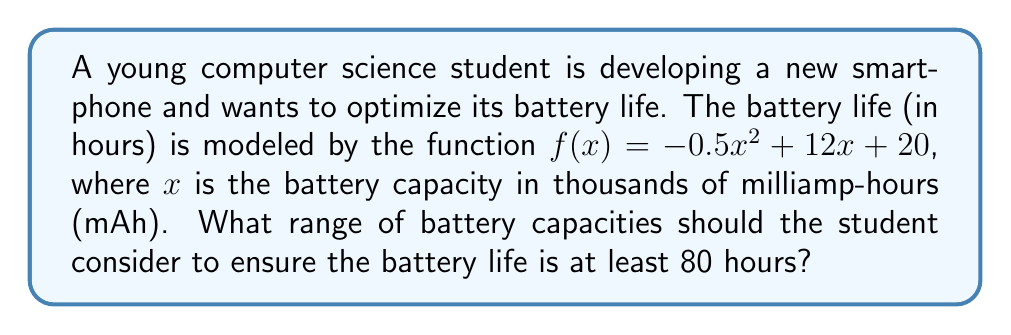Give your solution to this math problem. Let's approach this step-by-step:

1) We need to find the values of $x$ where $f(x) \geq 80$. This can be written as an inequality:

   $-0.5x^2 + 12x + 20 \geq 80$

2) Rearrange the inequality:
   
   $-0.5x^2 + 12x - 60 \geq 0$

3) This is a quadratic inequality. To solve it, we first find the roots of the corresponding quadratic equation:

   $-0.5x^2 + 12x - 60 = 0$

4) We can solve this using the quadratic formula: $x = \frac{-b \pm \sqrt{b^2 - 4ac}}{2a}$
   
   Here, $a = -0.5$, $b = 12$, and $c = -60$

5) Plugging into the formula:

   $x = \frac{-12 \pm \sqrt{12^2 - 4(-0.5)(-60)}}{2(-0.5)}$
   
   $= \frac{-12 \pm \sqrt{144 - 120}}{-1}$
   
   $= \frac{-12 \pm \sqrt{24}}{-1}$
   
   $= \frac{-12 \pm 4.9}{-1}$

6) This gives us two solutions:

   $x_1 = \frac{-12 - 4.9}{-1} \approx 16.9$
   
   $x_2 = \frac{-12 + 4.9}{-1} \approx 7.1$

7) Since the parabola opens downward (coefficient of $x^2$ is negative), the inequality $f(x) \geq 80$ is satisfied when $x$ is between these two roots.

Therefore, the range of battery capacities that ensure at least 80 hours of battery life is approximately 7.1 to 16.9 thousand mAh.
Answer: $7.1 \leq x \leq 16.9$ thousand mAh 